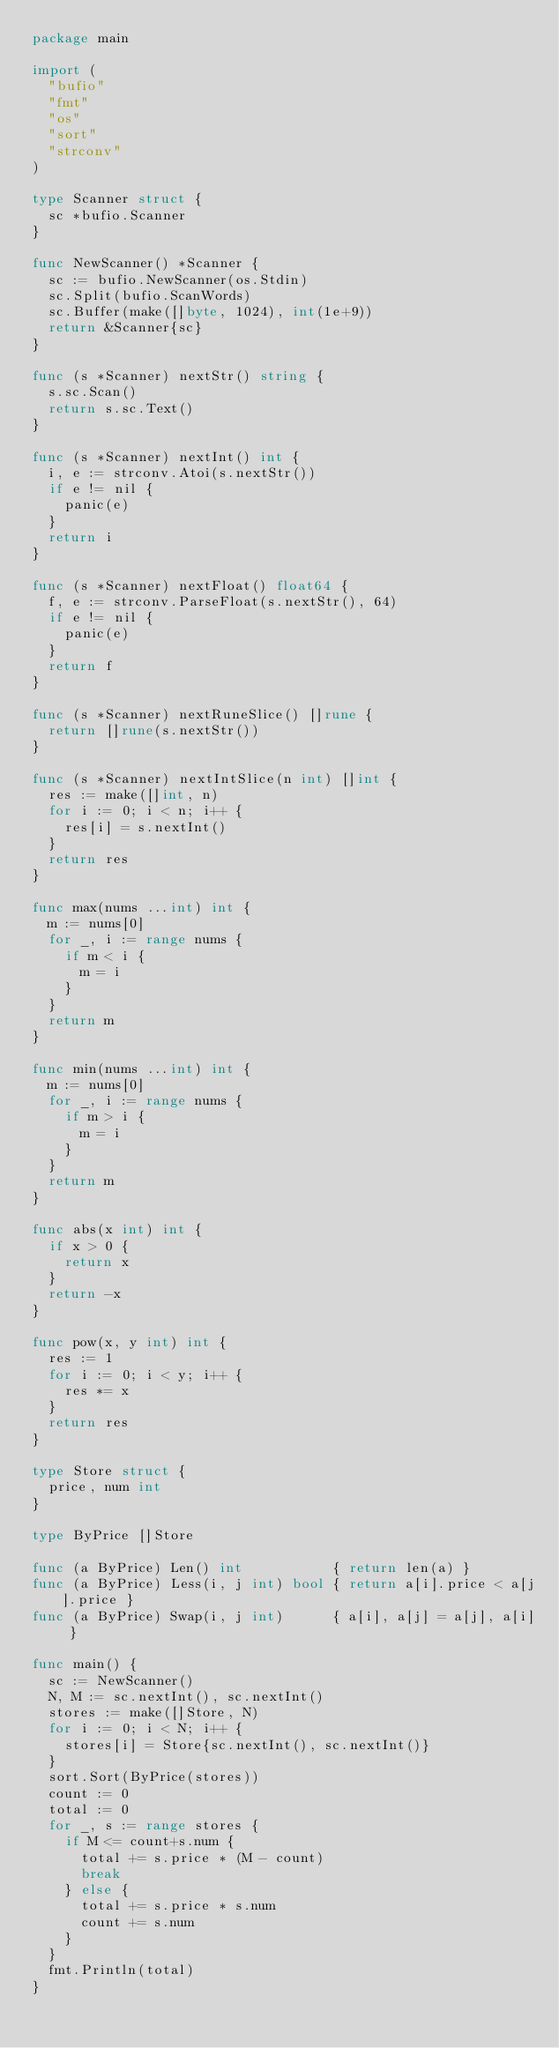<code> <loc_0><loc_0><loc_500><loc_500><_Go_>package main

import (
	"bufio"
	"fmt"
	"os"
	"sort"
	"strconv"
)

type Scanner struct {
	sc *bufio.Scanner
}

func NewScanner() *Scanner {
	sc := bufio.NewScanner(os.Stdin)
	sc.Split(bufio.ScanWords)
	sc.Buffer(make([]byte, 1024), int(1e+9))
	return &Scanner{sc}
}

func (s *Scanner) nextStr() string {
	s.sc.Scan()
	return s.sc.Text()
}

func (s *Scanner) nextInt() int {
	i, e := strconv.Atoi(s.nextStr())
	if e != nil {
		panic(e)
	}
	return i
}

func (s *Scanner) nextFloat() float64 {
	f, e := strconv.ParseFloat(s.nextStr(), 64)
	if e != nil {
		panic(e)
	}
	return f
}

func (s *Scanner) nextRuneSlice() []rune {
	return []rune(s.nextStr())
}

func (s *Scanner) nextIntSlice(n int) []int {
	res := make([]int, n)
	for i := 0; i < n; i++ {
		res[i] = s.nextInt()
	}
	return res
}

func max(nums ...int) int {
	m := nums[0]
	for _, i := range nums {
		if m < i {
			m = i
		}
	}
	return m
}

func min(nums ...int) int {
	m := nums[0]
	for _, i := range nums {
		if m > i {
			m = i
		}
	}
	return m
}

func abs(x int) int {
	if x > 0 {
		return x
	}
	return -x
}

func pow(x, y int) int {
	res := 1
	for i := 0; i < y; i++ {
		res *= x
	}
	return res
}

type Store struct {
	price, num int
}

type ByPrice []Store

func (a ByPrice) Len() int           { return len(a) }
func (a ByPrice) Less(i, j int) bool { return a[i].price < a[j].price }
func (a ByPrice) Swap(i, j int)      { a[i], a[j] = a[j], a[i] }

func main() {
	sc := NewScanner()
	N, M := sc.nextInt(), sc.nextInt()
	stores := make([]Store, N)
	for i := 0; i < N; i++ {
		stores[i] = Store{sc.nextInt(), sc.nextInt()}
	}
	sort.Sort(ByPrice(stores))
	count := 0
	total := 0
	for _, s := range stores {
		if M <= count+s.num {
			total += s.price * (M - count)
			break
		} else {
			total += s.price * s.num
			count += s.num
		}
	}
	fmt.Println(total)
}
</code> 